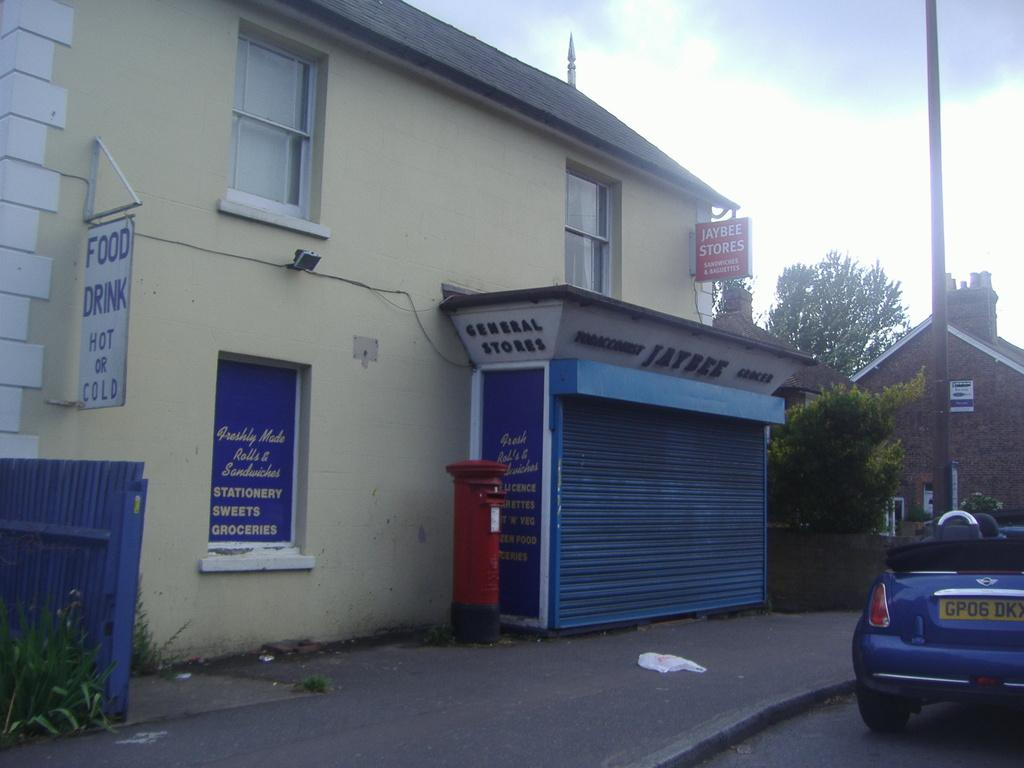What type of establishment is closed in the image? There is a closed store in the image. What other type of building is visible in the image? There is a house in the image. What natural elements can be seen in the image? There are trees in the image. How would you describe the weather based on the image? The sky is cloudy in the image. What man-made object is present in the image? There is a pole in the image. What mode of transportation is visible in the image? There is a parked car in the image. Can you tell me how many pictures of destruction are hanging on the wall in the image? There are no pictures of destruction present in the image. What type of bird can be seen flying in the image? There are no birds visible in the image. 